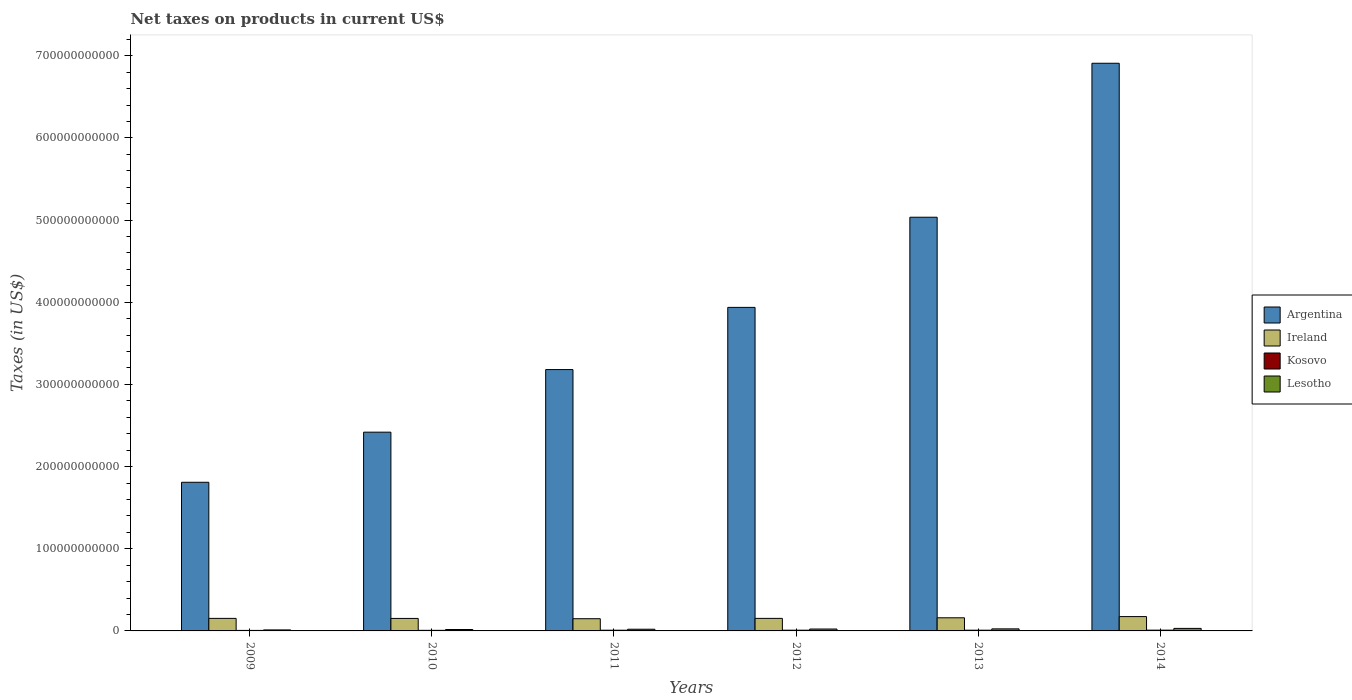How many groups of bars are there?
Keep it short and to the point. 6. Are the number of bars per tick equal to the number of legend labels?
Your response must be concise. Yes. How many bars are there on the 6th tick from the right?
Your answer should be compact. 4. What is the label of the 4th group of bars from the left?
Your answer should be compact. 2012. In how many cases, is the number of bars for a given year not equal to the number of legend labels?
Offer a very short reply. 0. What is the net taxes on products in Ireland in 2012?
Your answer should be compact. 1.53e+1. Across all years, what is the maximum net taxes on products in Ireland?
Your answer should be compact. 1.74e+1. Across all years, what is the minimum net taxes on products in Argentina?
Offer a terse response. 1.81e+11. In which year was the net taxes on products in Kosovo minimum?
Give a very brief answer. 2009. What is the total net taxes on products in Argentina in the graph?
Offer a terse response. 2.33e+12. What is the difference between the net taxes on products in Lesotho in 2010 and that in 2012?
Your answer should be compact. -5.82e+08. What is the difference between the net taxes on products in Ireland in 2011 and the net taxes on products in Kosovo in 2010?
Offer a terse response. 1.41e+1. What is the average net taxes on products in Ireland per year?
Offer a very short reply. 1.57e+1. In the year 2013, what is the difference between the net taxes on products in Lesotho and net taxes on products in Kosovo?
Give a very brief answer. 1.60e+09. What is the ratio of the net taxes on products in Argentina in 2010 to that in 2014?
Offer a very short reply. 0.35. What is the difference between the highest and the second highest net taxes on products in Argentina?
Provide a short and direct response. 1.87e+11. What is the difference between the highest and the lowest net taxes on products in Argentina?
Your answer should be compact. 5.10e+11. Is the sum of the net taxes on products in Argentina in 2011 and 2012 greater than the maximum net taxes on products in Ireland across all years?
Your answer should be compact. Yes. What does the 2nd bar from the left in 2009 represents?
Provide a succinct answer. Ireland. What does the 4th bar from the right in 2011 represents?
Ensure brevity in your answer.  Argentina. What is the difference between two consecutive major ticks on the Y-axis?
Your answer should be compact. 1.00e+11. Are the values on the major ticks of Y-axis written in scientific E-notation?
Offer a very short reply. No. Where does the legend appear in the graph?
Your answer should be compact. Center right. What is the title of the graph?
Your answer should be very brief. Net taxes on products in current US$. What is the label or title of the Y-axis?
Your answer should be very brief. Taxes (in US$). What is the Taxes (in US$) of Argentina in 2009?
Ensure brevity in your answer.  1.81e+11. What is the Taxes (in US$) of Ireland in 2009?
Provide a succinct answer. 1.53e+1. What is the Taxes (in US$) of Kosovo in 2009?
Your answer should be compact. 6.11e+08. What is the Taxes (in US$) in Lesotho in 2009?
Provide a succinct answer. 1.23e+09. What is the Taxes (in US$) of Argentina in 2010?
Your answer should be very brief. 2.42e+11. What is the Taxes (in US$) of Ireland in 2010?
Offer a very short reply. 1.52e+1. What is the Taxes (in US$) of Kosovo in 2010?
Give a very brief answer. 7.15e+08. What is the Taxes (in US$) in Lesotho in 2010?
Your answer should be very brief. 1.72e+09. What is the Taxes (in US$) of Argentina in 2011?
Give a very brief answer. 3.18e+11. What is the Taxes (in US$) of Ireland in 2011?
Ensure brevity in your answer.  1.49e+1. What is the Taxes (in US$) of Kosovo in 2011?
Provide a succinct answer. 8.70e+08. What is the Taxes (in US$) in Lesotho in 2011?
Your answer should be compact. 2.06e+09. What is the Taxes (in US$) of Argentina in 2012?
Offer a terse response. 3.94e+11. What is the Taxes (in US$) of Ireland in 2012?
Your answer should be very brief. 1.53e+1. What is the Taxes (in US$) of Kosovo in 2012?
Ensure brevity in your answer.  8.92e+08. What is the Taxes (in US$) in Lesotho in 2012?
Your answer should be very brief. 2.31e+09. What is the Taxes (in US$) in Argentina in 2013?
Provide a succinct answer. 5.03e+11. What is the Taxes (in US$) in Ireland in 2013?
Provide a short and direct response. 1.60e+1. What is the Taxes (in US$) of Kosovo in 2013?
Provide a short and direct response. 8.91e+08. What is the Taxes (in US$) in Lesotho in 2013?
Give a very brief answer. 2.49e+09. What is the Taxes (in US$) of Argentina in 2014?
Your answer should be very brief. 6.91e+11. What is the Taxes (in US$) in Ireland in 2014?
Your answer should be very brief. 1.74e+1. What is the Taxes (in US$) of Kosovo in 2014?
Keep it short and to the point. 9.50e+08. What is the Taxes (in US$) in Lesotho in 2014?
Ensure brevity in your answer.  3.06e+09. Across all years, what is the maximum Taxes (in US$) in Argentina?
Provide a short and direct response. 6.91e+11. Across all years, what is the maximum Taxes (in US$) of Ireland?
Provide a short and direct response. 1.74e+1. Across all years, what is the maximum Taxes (in US$) in Kosovo?
Make the answer very short. 9.50e+08. Across all years, what is the maximum Taxes (in US$) in Lesotho?
Offer a very short reply. 3.06e+09. Across all years, what is the minimum Taxes (in US$) in Argentina?
Offer a terse response. 1.81e+11. Across all years, what is the minimum Taxes (in US$) in Ireland?
Keep it short and to the point. 1.49e+1. Across all years, what is the minimum Taxes (in US$) of Kosovo?
Your response must be concise. 6.11e+08. Across all years, what is the minimum Taxes (in US$) of Lesotho?
Your answer should be very brief. 1.23e+09. What is the total Taxes (in US$) in Argentina in the graph?
Your answer should be compact. 2.33e+12. What is the total Taxes (in US$) of Ireland in the graph?
Your response must be concise. 9.40e+1. What is the total Taxes (in US$) of Kosovo in the graph?
Your answer should be compact. 4.93e+09. What is the total Taxes (in US$) in Lesotho in the graph?
Make the answer very short. 1.29e+1. What is the difference between the Taxes (in US$) of Argentina in 2009 and that in 2010?
Your answer should be compact. -6.10e+1. What is the difference between the Taxes (in US$) in Ireland in 2009 and that in 2010?
Give a very brief answer. 4.93e+07. What is the difference between the Taxes (in US$) in Kosovo in 2009 and that in 2010?
Make the answer very short. -1.04e+08. What is the difference between the Taxes (in US$) of Lesotho in 2009 and that in 2010?
Offer a very short reply. -4.92e+08. What is the difference between the Taxes (in US$) of Argentina in 2009 and that in 2011?
Ensure brevity in your answer.  -1.37e+11. What is the difference between the Taxes (in US$) of Ireland in 2009 and that in 2011?
Make the answer very short. 3.92e+08. What is the difference between the Taxes (in US$) in Kosovo in 2009 and that in 2011?
Ensure brevity in your answer.  -2.59e+08. What is the difference between the Taxes (in US$) in Lesotho in 2009 and that in 2011?
Provide a succinct answer. -8.29e+08. What is the difference between the Taxes (in US$) of Argentina in 2009 and that in 2012?
Your response must be concise. -2.13e+11. What is the difference between the Taxes (in US$) in Ireland in 2009 and that in 2012?
Your response must be concise. -3.98e+06. What is the difference between the Taxes (in US$) in Kosovo in 2009 and that in 2012?
Provide a succinct answer. -2.81e+08. What is the difference between the Taxes (in US$) of Lesotho in 2009 and that in 2012?
Your answer should be very brief. -1.07e+09. What is the difference between the Taxes (in US$) in Argentina in 2009 and that in 2013?
Your response must be concise. -3.23e+11. What is the difference between the Taxes (in US$) of Ireland in 2009 and that in 2013?
Offer a terse response. -7.23e+08. What is the difference between the Taxes (in US$) in Kosovo in 2009 and that in 2013?
Your answer should be compact. -2.80e+08. What is the difference between the Taxes (in US$) in Lesotho in 2009 and that in 2013?
Ensure brevity in your answer.  -1.26e+09. What is the difference between the Taxes (in US$) in Argentina in 2009 and that in 2014?
Your answer should be very brief. -5.10e+11. What is the difference between the Taxes (in US$) in Ireland in 2009 and that in 2014?
Offer a terse response. -2.19e+09. What is the difference between the Taxes (in US$) of Kosovo in 2009 and that in 2014?
Offer a terse response. -3.39e+08. What is the difference between the Taxes (in US$) of Lesotho in 2009 and that in 2014?
Give a very brief answer. -1.83e+09. What is the difference between the Taxes (in US$) in Argentina in 2010 and that in 2011?
Your answer should be very brief. -7.62e+1. What is the difference between the Taxes (in US$) in Ireland in 2010 and that in 2011?
Keep it short and to the point. 3.43e+08. What is the difference between the Taxes (in US$) of Kosovo in 2010 and that in 2011?
Provide a short and direct response. -1.55e+08. What is the difference between the Taxes (in US$) of Lesotho in 2010 and that in 2011?
Offer a terse response. -3.37e+08. What is the difference between the Taxes (in US$) of Argentina in 2010 and that in 2012?
Keep it short and to the point. -1.52e+11. What is the difference between the Taxes (in US$) in Ireland in 2010 and that in 2012?
Keep it short and to the point. -5.33e+07. What is the difference between the Taxes (in US$) in Kosovo in 2010 and that in 2012?
Provide a succinct answer. -1.77e+08. What is the difference between the Taxes (in US$) of Lesotho in 2010 and that in 2012?
Provide a succinct answer. -5.82e+08. What is the difference between the Taxes (in US$) in Argentina in 2010 and that in 2013?
Provide a succinct answer. -2.62e+11. What is the difference between the Taxes (in US$) in Ireland in 2010 and that in 2013?
Ensure brevity in your answer.  -7.73e+08. What is the difference between the Taxes (in US$) in Kosovo in 2010 and that in 2013?
Keep it short and to the point. -1.76e+08. What is the difference between the Taxes (in US$) of Lesotho in 2010 and that in 2013?
Provide a succinct answer. -7.69e+08. What is the difference between the Taxes (in US$) in Argentina in 2010 and that in 2014?
Provide a succinct answer. -4.49e+11. What is the difference between the Taxes (in US$) of Ireland in 2010 and that in 2014?
Give a very brief answer. -2.24e+09. What is the difference between the Taxes (in US$) of Kosovo in 2010 and that in 2014?
Keep it short and to the point. -2.35e+08. What is the difference between the Taxes (in US$) of Lesotho in 2010 and that in 2014?
Make the answer very short. -1.34e+09. What is the difference between the Taxes (in US$) in Argentina in 2011 and that in 2012?
Offer a very short reply. -7.57e+1. What is the difference between the Taxes (in US$) of Ireland in 2011 and that in 2012?
Give a very brief answer. -3.96e+08. What is the difference between the Taxes (in US$) of Kosovo in 2011 and that in 2012?
Provide a short and direct response. -2.21e+07. What is the difference between the Taxes (in US$) in Lesotho in 2011 and that in 2012?
Keep it short and to the point. -2.45e+08. What is the difference between the Taxes (in US$) of Argentina in 2011 and that in 2013?
Offer a terse response. -1.85e+11. What is the difference between the Taxes (in US$) in Ireland in 2011 and that in 2013?
Your answer should be very brief. -1.12e+09. What is the difference between the Taxes (in US$) in Kosovo in 2011 and that in 2013?
Offer a terse response. -2.14e+07. What is the difference between the Taxes (in US$) of Lesotho in 2011 and that in 2013?
Provide a short and direct response. -4.32e+08. What is the difference between the Taxes (in US$) of Argentina in 2011 and that in 2014?
Offer a very short reply. -3.73e+11. What is the difference between the Taxes (in US$) of Ireland in 2011 and that in 2014?
Your answer should be very brief. -2.58e+09. What is the difference between the Taxes (in US$) in Kosovo in 2011 and that in 2014?
Provide a succinct answer. -8.03e+07. What is the difference between the Taxes (in US$) of Lesotho in 2011 and that in 2014?
Provide a succinct answer. -1.00e+09. What is the difference between the Taxes (in US$) in Argentina in 2012 and that in 2013?
Provide a short and direct response. -1.10e+11. What is the difference between the Taxes (in US$) in Ireland in 2012 and that in 2013?
Provide a short and direct response. -7.19e+08. What is the difference between the Taxes (in US$) of Lesotho in 2012 and that in 2013?
Provide a short and direct response. -1.87e+08. What is the difference between the Taxes (in US$) in Argentina in 2012 and that in 2014?
Ensure brevity in your answer.  -2.97e+11. What is the difference between the Taxes (in US$) of Ireland in 2012 and that in 2014?
Offer a terse response. -2.18e+09. What is the difference between the Taxes (in US$) of Kosovo in 2012 and that in 2014?
Your answer should be very brief. -5.82e+07. What is the difference between the Taxes (in US$) in Lesotho in 2012 and that in 2014?
Make the answer very short. -7.56e+08. What is the difference between the Taxes (in US$) of Argentina in 2013 and that in 2014?
Ensure brevity in your answer.  -1.87e+11. What is the difference between the Taxes (in US$) of Ireland in 2013 and that in 2014?
Make the answer very short. -1.47e+09. What is the difference between the Taxes (in US$) of Kosovo in 2013 and that in 2014?
Give a very brief answer. -5.89e+07. What is the difference between the Taxes (in US$) in Lesotho in 2013 and that in 2014?
Keep it short and to the point. -5.69e+08. What is the difference between the Taxes (in US$) in Argentina in 2009 and the Taxes (in US$) in Ireland in 2010?
Offer a very short reply. 1.66e+11. What is the difference between the Taxes (in US$) of Argentina in 2009 and the Taxes (in US$) of Kosovo in 2010?
Your answer should be very brief. 1.80e+11. What is the difference between the Taxes (in US$) of Argentina in 2009 and the Taxes (in US$) of Lesotho in 2010?
Your response must be concise. 1.79e+11. What is the difference between the Taxes (in US$) in Ireland in 2009 and the Taxes (in US$) in Kosovo in 2010?
Provide a short and direct response. 1.45e+1. What is the difference between the Taxes (in US$) of Ireland in 2009 and the Taxes (in US$) of Lesotho in 2010?
Offer a terse response. 1.35e+1. What is the difference between the Taxes (in US$) of Kosovo in 2009 and the Taxes (in US$) of Lesotho in 2010?
Your answer should be very brief. -1.11e+09. What is the difference between the Taxes (in US$) of Argentina in 2009 and the Taxes (in US$) of Ireland in 2011?
Offer a very short reply. 1.66e+11. What is the difference between the Taxes (in US$) of Argentina in 2009 and the Taxes (in US$) of Kosovo in 2011?
Your response must be concise. 1.80e+11. What is the difference between the Taxes (in US$) of Argentina in 2009 and the Taxes (in US$) of Lesotho in 2011?
Provide a succinct answer. 1.79e+11. What is the difference between the Taxes (in US$) of Ireland in 2009 and the Taxes (in US$) of Kosovo in 2011?
Ensure brevity in your answer.  1.44e+1. What is the difference between the Taxes (in US$) in Ireland in 2009 and the Taxes (in US$) in Lesotho in 2011?
Make the answer very short. 1.32e+1. What is the difference between the Taxes (in US$) in Kosovo in 2009 and the Taxes (in US$) in Lesotho in 2011?
Provide a succinct answer. -1.45e+09. What is the difference between the Taxes (in US$) in Argentina in 2009 and the Taxes (in US$) in Ireland in 2012?
Provide a succinct answer. 1.66e+11. What is the difference between the Taxes (in US$) of Argentina in 2009 and the Taxes (in US$) of Kosovo in 2012?
Provide a short and direct response. 1.80e+11. What is the difference between the Taxes (in US$) of Argentina in 2009 and the Taxes (in US$) of Lesotho in 2012?
Your response must be concise. 1.79e+11. What is the difference between the Taxes (in US$) of Ireland in 2009 and the Taxes (in US$) of Kosovo in 2012?
Your answer should be compact. 1.44e+1. What is the difference between the Taxes (in US$) in Ireland in 2009 and the Taxes (in US$) in Lesotho in 2012?
Provide a succinct answer. 1.29e+1. What is the difference between the Taxes (in US$) of Kosovo in 2009 and the Taxes (in US$) of Lesotho in 2012?
Ensure brevity in your answer.  -1.70e+09. What is the difference between the Taxes (in US$) in Argentina in 2009 and the Taxes (in US$) in Ireland in 2013?
Your answer should be very brief. 1.65e+11. What is the difference between the Taxes (in US$) in Argentina in 2009 and the Taxes (in US$) in Kosovo in 2013?
Your response must be concise. 1.80e+11. What is the difference between the Taxes (in US$) in Argentina in 2009 and the Taxes (in US$) in Lesotho in 2013?
Provide a succinct answer. 1.78e+11. What is the difference between the Taxes (in US$) of Ireland in 2009 and the Taxes (in US$) of Kosovo in 2013?
Your answer should be very brief. 1.44e+1. What is the difference between the Taxes (in US$) of Ireland in 2009 and the Taxes (in US$) of Lesotho in 2013?
Your response must be concise. 1.28e+1. What is the difference between the Taxes (in US$) in Kosovo in 2009 and the Taxes (in US$) in Lesotho in 2013?
Offer a very short reply. -1.88e+09. What is the difference between the Taxes (in US$) in Argentina in 2009 and the Taxes (in US$) in Ireland in 2014?
Make the answer very short. 1.63e+11. What is the difference between the Taxes (in US$) in Argentina in 2009 and the Taxes (in US$) in Kosovo in 2014?
Ensure brevity in your answer.  1.80e+11. What is the difference between the Taxes (in US$) in Argentina in 2009 and the Taxes (in US$) in Lesotho in 2014?
Ensure brevity in your answer.  1.78e+11. What is the difference between the Taxes (in US$) in Ireland in 2009 and the Taxes (in US$) in Kosovo in 2014?
Keep it short and to the point. 1.43e+1. What is the difference between the Taxes (in US$) in Ireland in 2009 and the Taxes (in US$) in Lesotho in 2014?
Offer a very short reply. 1.22e+1. What is the difference between the Taxes (in US$) in Kosovo in 2009 and the Taxes (in US$) in Lesotho in 2014?
Your answer should be compact. -2.45e+09. What is the difference between the Taxes (in US$) in Argentina in 2010 and the Taxes (in US$) in Ireland in 2011?
Your answer should be compact. 2.27e+11. What is the difference between the Taxes (in US$) in Argentina in 2010 and the Taxes (in US$) in Kosovo in 2011?
Offer a terse response. 2.41e+11. What is the difference between the Taxes (in US$) in Argentina in 2010 and the Taxes (in US$) in Lesotho in 2011?
Provide a succinct answer. 2.40e+11. What is the difference between the Taxes (in US$) of Ireland in 2010 and the Taxes (in US$) of Kosovo in 2011?
Your answer should be compact. 1.43e+1. What is the difference between the Taxes (in US$) of Ireland in 2010 and the Taxes (in US$) of Lesotho in 2011?
Your answer should be very brief. 1.31e+1. What is the difference between the Taxes (in US$) in Kosovo in 2010 and the Taxes (in US$) in Lesotho in 2011?
Offer a very short reply. -1.35e+09. What is the difference between the Taxes (in US$) of Argentina in 2010 and the Taxes (in US$) of Ireland in 2012?
Offer a terse response. 2.27e+11. What is the difference between the Taxes (in US$) in Argentina in 2010 and the Taxes (in US$) in Kosovo in 2012?
Give a very brief answer. 2.41e+11. What is the difference between the Taxes (in US$) of Argentina in 2010 and the Taxes (in US$) of Lesotho in 2012?
Give a very brief answer. 2.40e+11. What is the difference between the Taxes (in US$) of Ireland in 2010 and the Taxes (in US$) of Kosovo in 2012?
Your answer should be compact. 1.43e+1. What is the difference between the Taxes (in US$) in Ireland in 2010 and the Taxes (in US$) in Lesotho in 2012?
Ensure brevity in your answer.  1.29e+1. What is the difference between the Taxes (in US$) in Kosovo in 2010 and the Taxes (in US$) in Lesotho in 2012?
Your answer should be compact. -1.59e+09. What is the difference between the Taxes (in US$) in Argentina in 2010 and the Taxes (in US$) in Ireland in 2013?
Provide a succinct answer. 2.26e+11. What is the difference between the Taxes (in US$) of Argentina in 2010 and the Taxes (in US$) of Kosovo in 2013?
Your response must be concise. 2.41e+11. What is the difference between the Taxes (in US$) in Argentina in 2010 and the Taxes (in US$) in Lesotho in 2013?
Offer a very short reply. 2.39e+11. What is the difference between the Taxes (in US$) of Ireland in 2010 and the Taxes (in US$) of Kosovo in 2013?
Provide a short and direct response. 1.43e+1. What is the difference between the Taxes (in US$) of Ireland in 2010 and the Taxes (in US$) of Lesotho in 2013?
Ensure brevity in your answer.  1.27e+1. What is the difference between the Taxes (in US$) of Kosovo in 2010 and the Taxes (in US$) of Lesotho in 2013?
Offer a very short reply. -1.78e+09. What is the difference between the Taxes (in US$) of Argentina in 2010 and the Taxes (in US$) of Ireland in 2014?
Your response must be concise. 2.24e+11. What is the difference between the Taxes (in US$) in Argentina in 2010 and the Taxes (in US$) in Kosovo in 2014?
Offer a terse response. 2.41e+11. What is the difference between the Taxes (in US$) in Argentina in 2010 and the Taxes (in US$) in Lesotho in 2014?
Offer a very short reply. 2.39e+11. What is the difference between the Taxes (in US$) in Ireland in 2010 and the Taxes (in US$) in Kosovo in 2014?
Make the answer very short. 1.43e+1. What is the difference between the Taxes (in US$) in Ireland in 2010 and the Taxes (in US$) in Lesotho in 2014?
Keep it short and to the point. 1.21e+1. What is the difference between the Taxes (in US$) in Kosovo in 2010 and the Taxes (in US$) in Lesotho in 2014?
Provide a succinct answer. -2.35e+09. What is the difference between the Taxes (in US$) of Argentina in 2011 and the Taxes (in US$) of Ireland in 2012?
Give a very brief answer. 3.03e+11. What is the difference between the Taxes (in US$) in Argentina in 2011 and the Taxes (in US$) in Kosovo in 2012?
Give a very brief answer. 3.17e+11. What is the difference between the Taxes (in US$) in Argentina in 2011 and the Taxes (in US$) in Lesotho in 2012?
Provide a succinct answer. 3.16e+11. What is the difference between the Taxes (in US$) in Ireland in 2011 and the Taxes (in US$) in Kosovo in 2012?
Ensure brevity in your answer.  1.40e+1. What is the difference between the Taxes (in US$) of Ireland in 2011 and the Taxes (in US$) of Lesotho in 2012?
Keep it short and to the point. 1.26e+1. What is the difference between the Taxes (in US$) in Kosovo in 2011 and the Taxes (in US$) in Lesotho in 2012?
Ensure brevity in your answer.  -1.44e+09. What is the difference between the Taxes (in US$) of Argentina in 2011 and the Taxes (in US$) of Ireland in 2013?
Give a very brief answer. 3.02e+11. What is the difference between the Taxes (in US$) in Argentina in 2011 and the Taxes (in US$) in Kosovo in 2013?
Your answer should be very brief. 3.17e+11. What is the difference between the Taxes (in US$) of Argentina in 2011 and the Taxes (in US$) of Lesotho in 2013?
Offer a terse response. 3.16e+11. What is the difference between the Taxes (in US$) in Ireland in 2011 and the Taxes (in US$) in Kosovo in 2013?
Make the answer very short. 1.40e+1. What is the difference between the Taxes (in US$) in Ireland in 2011 and the Taxes (in US$) in Lesotho in 2013?
Keep it short and to the point. 1.24e+1. What is the difference between the Taxes (in US$) of Kosovo in 2011 and the Taxes (in US$) of Lesotho in 2013?
Your answer should be compact. -1.62e+09. What is the difference between the Taxes (in US$) in Argentina in 2011 and the Taxes (in US$) in Ireland in 2014?
Provide a succinct answer. 3.01e+11. What is the difference between the Taxes (in US$) in Argentina in 2011 and the Taxes (in US$) in Kosovo in 2014?
Ensure brevity in your answer.  3.17e+11. What is the difference between the Taxes (in US$) in Argentina in 2011 and the Taxes (in US$) in Lesotho in 2014?
Your answer should be compact. 3.15e+11. What is the difference between the Taxes (in US$) in Ireland in 2011 and the Taxes (in US$) in Kosovo in 2014?
Your answer should be very brief. 1.39e+1. What is the difference between the Taxes (in US$) in Ireland in 2011 and the Taxes (in US$) in Lesotho in 2014?
Give a very brief answer. 1.18e+1. What is the difference between the Taxes (in US$) in Kosovo in 2011 and the Taxes (in US$) in Lesotho in 2014?
Make the answer very short. -2.19e+09. What is the difference between the Taxes (in US$) in Argentina in 2012 and the Taxes (in US$) in Ireland in 2013?
Give a very brief answer. 3.78e+11. What is the difference between the Taxes (in US$) in Argentina in 2012 and the Taxes (in US$) in Kosovo in 2013?
Offer a very short reply. 3.93e+11. What is the difference between the Taxes (in US$) of Argentina in 2012 and the Taxes (in US$) of Lesotho in 2013?
Provide a short and direct response. 3.91e+11. What is the difference between the Taxes (in US$) of Ireland in 2012 and the Taxes (in US$) of Kosovo in 2013?
Make the answer very short. 1.44e+1. What is the difference between the Taxes (in US$) of Ireland in 2012 and the Taxes (in US$) of Lesotho in 2013?
Make the answer very short. 1.28e+1. What is the difference between the Taxes (in US$) of Kosovo in 2012 and the Taxes (in US$) of Lesotho in 2013?
Provide a succinct answer. -1.60e+09. What is the difference between the Taxes (in US$) in Argentina in 2012 and the Taxes (in US$) in Ireland in 2014?
Make the answer very short. 3.76e+11. What is the difference between the Taxes (in US$) in Argentina in 2012 and the Taxes (in US$) in Kosovo in 2014?
Offer a terse response. 3.93e+11. What is the difference between the Taxes (in US$) in Argentina in 2012 and the Taxes (in US$) in Lesotho in 2014?
Keep it short and to the point. 3.91e+11. What is the difference between the Taxes (in US$) of Ireland in 2012 and the Taxes (in US$) of Kosovo in 2014?
Provide a succinct answer. 1.43e+1. What is the difference between the Taxes (in US$) of Ireland in 2012 and the Taxes (in US$) of Lesotho in 2014?
Your answer should be very brief. 1.22e+1. What is the difference between the Taxes (in US$) in Kosovo in 2012 and the Taxes (in US$) in Lesotho in 2014?
Your answer should be compact. -2.17e+09. What is the difference between the Taxes (in US$) of Argentina in 2013 and the Taxes (in US$) of Ireland in 2014?
Make the answer very short. 4.86e+11. What is the difference between the Taxes (in US$) in Argentina in 2013 and the Taxes (in US$) in Kosovo in 2014?
Keep it short and to the point. 5.03e+11. What is the difference between the Taxes (in US$) in Argentina in 2013 and the Taxes (in US$) in Lesotho in 2014?
Offer a terse response. 5.00e+11. What is the difference between the Taxes (in US$) in Ireland in 2013 and the Taxes (in US$) in Kosovo in 2014?
Your answer should be compact. 1.50e+1. What is the difference between the Taxes (in US$) of Ireland in 2013 and the Taxes (in US$) of Lesotho in 2014?
Offer a terse response. 1.29e+1. What is the difference between the Taxes (in US$) of Kosovo in 2013 and the Taxes (in US$) of Lesotho in 2014?
Your answer should be compact. -2.17e+09. What is the average Taxes (in US$) in Argentina per year?
Provide a succinct answer. 3.88e+11. What is the average Taxes (in US$) of Ireland per year?
Provide a short and direct response. 1.57e+1. What is the average Taxes (in US$) in Kosovo per year?
Your response must be concise. 8.21e+08. What is the average Taxes (in US$) of Lesotho per year?
Your answer should be very brief. 2.15e+09. In the year 2009, what is the difference between the Taxes (in US$) of Argentina and Taxes (in US$) of Ireland?
Ensure brevity in your answer.  1.66e+11. In the year 2009, what is the difference between the Taxes (in US$) of Argentina and Taxes (in US$) of Kosovo?
Ensure brevity in your answer.  1.80e+11. In the year 2009, what is the difference between the Taxes (in US$) in Argentina and Taxes (in US$) in Lesotho?
Make the answer very short. 1.80e+11. In the year 2009, what is the difference between the Taxes (in US$) in Ireland and Taxes (in US$) in Kosovo?
Your response must be concise. 1.46e+1. In the year 2009, what is the difference between the Taxes (in US$) in Ireland and Taxes (in US$) in Lesotho?
Provide a short and direct response. 1.40e+1. In the year 2009, what is the difference between the Taxes (in US$) of Kosovo and Taxes (in US$) of Lesotho?
Your answer should be compact. -6.21e+08. In the year 2010, what is the difference between the Taxes (in US$) of Argentina and Taxes (in US$) of Ireland?
Offer a terse response. 2.27e+11. In the year 2010, what is the difference between the Taxes (in US$) of Argentina and Taxes (in US$) of Kosovo?
Your answer should be compact. 2.41e+11. In the year 2010, what is the difference between the Taxes (in US$) in Argentina and Taxes (in US$) in Lesotho?
Keep it short and to the point. 2.40e+11. In the year 2010, what is the difference between the Taxes (in US$) in Ireland and Taxes (in US$) in Kosovo?
Your answer should be compact. 1.45e+1. In the year 2010, what is the difference between the Taxes (in US$) of Ireland and Taxes (in US$) of Lesotho?
Offer a terse response. 1.35e+1. In the year 2010, what is the difference between the Taxes (in US$) in Kosovo and Taxes (in US$) in Lesotho?
Make the answer very short. -1.01e+09. In the year 2011, what is the difference between the Taxes (in US$) in Argentina and Taxes (in US$) in Ireland?
Your answer should be compact. 3.03e+11. In the year 2011, what is the difference between the Taxes (in US$) in Argentina and Taxes (in US$) in Kosovo?
Ensure brevity in your answer.  3.17e+11. In the year 2011, what is the difference between the Taxes (in US$) of Argentina and Taxes (in US$) of Lesotho?
Ensure brevity in your answer.  3.16e+11. In the year 2011, what is the difference between the Taxes (in US$) in Ireland and Taxes (in US$) in Kosovo?
Give a very brief answer. 1.40e+1. In the year 2011, what is the difference between the Taxes (in US$) of Ireland and Taxes (in US$) of Lesotho?
Make the answer very short. 1.28e+1. In the year 2011, what is the difference between the Taxes (in US$) of Kosovo and Taxes (in US$) of Lesotho?
Make the answer very short. -1.19e+09. In the year 2012, what is the difference between the Taxes (in US$) in Argentina and Taxes (in US$) in Ireland?
Your response must be concise. 3.78e+11. In the year 2012, what is the difference between the Taxes (in US$) in Argentina and Taxes (in US$) in Kosovo?
Provide a short and direct response. 3.93e+11. In the year 2012, what is the difference between the Taxes (in US$) in Argentina and Taxes (in US$) in Lesotho?
Offer a very short reply. 3.91e+11. In the year 2012, what is the difference between the Taxes (in US$) in Ireland and Taxes (in US$) in Kosovo?
Provide a succinct answer. 1.44e+1. In the year 2012, what is the difference between the Taxes (in US$) in Ireland and Taxes (in US$) in Lesotho?
Give a very brief answer. 1.29e+1. In the year 2012, what is the difference between the Taxes (in US$) in Kosovo and Taxes (in US$) in Lesotho?
Provide a short and direct response. -1.41e+09. In the year 2013, what is the difference between the Taxes (in US$) in Argentina and Taxes (in US$) in Ireland?
Ensure brevity in your answer.  4.87e+11. In the year 2013, what is the difference between the Taxes (in US$) in Argentina and Taxes (in US$) in Kosovo?
Your answer should be compact. 5.03e+11. In the year 2013, what is the difference between the Taxes (in US$) in Argentina and Taxes (in US$) in Lesotho?
Your response must be concise. 5.01e+11. In the year 2013, what is the difference between the Taxes (in US$) in Ireland and Taxes (in US$) in Kosovo?
Offer a very short reply. 1.51e+1. In the year 2013, what is the difference between the Taxes (in US$) in Ireland and Taxes (in US$) in Lesotho?
Offer a very short reply. 1.35e+1. In the year 2013, what is the difference between the Taxes (in US$) of Kosovo and Taxes (in US$) of Lesotho?
Keep it short and to the point. -1.60e+09. In the year 2014, what is the difference between the Taxes (in US$) of Argentina and Taxes (in US$) of Ireland?
Make the answer very short. 6.73e+11. In the year 2014, what is the difference between the Taxes (in US$) of Argentina and Taxes (in US$) of Kosovo?
Your response must be concise. 6.90e+11. In the year 2014, what is the difference between the Taxes (in US$) of Argentina and Taxes (in US$) of Lesotho?
Offer a very short reply. 6.88e+11. In the year 2014, what is the difference between the Taxes (in US$) of Ireland and Taxes (in US$) of Kosovo?
Offer a terse response. 1.65e+1. In the year 2014, what is the difference between the Taxes (in US$) of Ireland and Taxes (in US$) of Lesotho?
Give a very brief answer. 1.44e+1. In the year 2014, what is the difference between the Taxes (in US$) in Kosovo and Taxes (in US$) in Lesotho?
Offer a terse response. -2.11e+09. What is the ratio of the Taxes (in US$) of Argentina in 2009 to that in 2010?
Your answer should be compact. 0.75. What is the ratio of the Taxes (in US$) in Ireland in 2009 to that in 2010?
Keep it short and to the point. 1. What is the ratio of the Taxes (in US$) in Kosovo in 2009 to that in 2010?
Keep it short and to the point. 0.85. What is the ratio of the Taxes (in US$) of Lesotho in 2009 to that in 2010?
Give a very brief answer. 0.71. What is the ratio of the Taxes (in US$) of Argentina in 2009 to that in 2011?
Your response must be concise. 0.57. What is the ratio of the Taxes (in US$) in Ireland in 2009 to that in 2011?
Offer a very short reply. 1.03. What is the ratio of the Taxes (in US$) in Kosovo in 2009 to that in 2011?
Offer a very short reply. 0.7. What is the ratio of the Taxes (in US$) in Lesotho in 2009 to that in 2011?
Your answer should be compact. 0.6. What is the ratio of the Taxes (in US$) in Argentina in 2009 to that in 2012?
Your response must be concise. 0.46. What is the ratio of the Taxes (in US$) of Kosovo in 2009 to that in 2012?
Give a very brief answer. 0.68. What is the ratio of the Taxes (in US$) in Lesotho in 2009 to that in 2012?
Provide a succinct answer. 0.53. What is the ratio of the Taxes (in US$) in Argentina in 2009 to that in 2013?
Your answer should be compact. 0.36. What is the ratio of the Taxes (in US$) of Ireland in 2009 to that in 2013?
Provide a succinct answer. 0.95. What is the ratio of the Taxes (in US$) in Kosovo in 2009 to that in 2013?
Your answer should be very brief. 0.69. What is the ratio of the Taxes (in US$) in Lesotho in 2009 to that in 2013?
Your response must be concise. 0.49. What is the ratio of the Taxes (in US$) in Argentina in 2009 to that in 2014?
Ensure brevity in your answer.  0.26. What is the ratio of the Taxes (in US$) of Ireland in 2009 to that in 2014?
Your response must be concise. 0.87. What is the ratio of the Taxes (in US$) of Kosovo in 2009 to that in 2014?
Offer a very short reply. 0.64. What is the ratio of the Taxes (in US$) of Lesotho in 2009 to that in 2014?
Keep it short and to the point. 0.4. What is the ratio of the Taxes (in US$) in Argentina in 2010 to that in 2011?
Give a very brief answer. 0.76. What is the ratio of the Taxes (in US$) in Ireland in 2010 to that in 2011?
Ensure brevity in your answer.  1.02. What is the ratio of the Taxes (in US$) of Kosovo in 2010 to that in 2011?
Make the answer very short. 0.82. What is the ratio of the Taxes (in US$) of Lesotho in 2010 to that in 2011?
Give a very brief answer. 0.84. What is the ratio of the Taxes (in US$) in Argentina in 2010 to that in 2012?
Give a very brief answer. 0.61. What is the ratio of the Taxes (in US$) in Kosovo in 2010 to that in 2012?
Your answer should be very brief. 0.8. What is the ratio of the Taxes (in US$) of Lesotho in 2010 to that in 2012?
Offer a very short reply. 0.75. What is the ratio of the Taxes (in US$) of Argentina in 2010 to that in 2013?
Give a very brief answer. 0.48. What is the ratio of the Taxes (in US$) in Ireland in 2010 to that in 2013?
Ensure brevity in your answer.  0.95. What is the ratio of the Taxes (in US$) of Kosovo in 2010 to that in 2013?
Offer a terse response. 0.8. What is the ratio of the Taxes (in US$) in Lesotho in 2010 to that in 2013?
Provide a succinct answer. 0.69. What is the ratio of the Taxes (in US$) in Argentina in 2010 to that in 2014?
Keep it short and to the point. 0.35. What is the ratio of the Taxes (in US$) of Ireland in 2010 to that in 2014?
Keep it short and to the point. 0.87. What is the ratio of the Taxes (in US$) in Kosovo in 2010 to that in 2014?
Provide a succinct answer. 0.75. What is the ratio of the Taxes (in US$) of Lesotho in 2010 to that in 2014?
Your response must be concise. 0.56. What is the ratio of the Taxes (in US$) of Argentina in 2011 to that in 2012?
Your answer should be very brief. 0.81. What is the ratio of the Taxes (in US$) in Kosovo in 2011 to that in 2012?
Keep it short and to the point. 0.98. What is the ratio of the Taxes (in US$) of Lesotho in 2011 to that in 2012?
Ensure brevity in your answer.  0.89. What is the ratio of the Taxes (in US$) of Argentina in 2011 to that in 2013?
Your response must be concise. 0.63. What is the ratio of the Taxes (in US$) in Ireland in 2011 to that in 2013?
Offer a very short reply. 0.93. What is the ratio of the Taxes (in US$) in Kosovo in 2011 to that in 2013?
Make the answer very short. 0.98. What is the ratio of the Taxes (in US$) in Lesotho in 2011 to that in 2013?
Give a very brief answer. 0.83. What is the ratio of the Taxes (in US$) of Argentina in 2011 to that in 2014?
Keep it short and to the point. 0.46. What is the ratio of the Taxes (in US$) in Ireland in 2011 to that in 2014?
Your answer should be very brief. 0.85. What is the ratio of the Taxes (in US$) in Kosovo in 2011 to that in 2014?
Provide a short and direct response. 0.92. What is the ratio of the Taxes (in US$) of Lesotho in 2011 to that in 2014?
Give a very brief answer. 0.67. What is the ratio of the Taxes (in US$) in Argentina in 2012 to that in 2013?
Give a very brief answer. 0.78. What is the ratio of the Taxes (in US$) of Ireland in 2012 to that in 2013?
Give a very brief answer. 0.95. What is the ratio of the Taxes (in US$) in Lesotho in 2012 to that in 2013?
Provide a succinct answer. 0.93. What is the ratio of the Taxes (in US$) in Argentina in 2012 to that in 2014?
Give a very brief answer. 0.57. What is the ratio of the Taxes (in US$) of Ireland in 2012 to that in 2014?
Ensure brevity in your answer.  0.87. What is the ratio of the Taxes (in US$) in Kosovo in 2012 to that in 2014?
Provide a short and direct response. 0.94. What is the ratio of the Taxes (in US$) in Lesotho in 2012 to that in 2014?
Offer a terse response. 0.75. What is the ratio of the Taxes (in US$) of Argentina in 2013 to that in 2014?
Provide a succinct answer. 0.73. What is the ratio of the Taxes (in US$) in Ireland in 2013 to that in 2014?
Keep it short and to the point. 0.92. What is the ratio of the Taxes (in US$) of Kosovo in 2013 to that in 2014?
Keep it short and to the point. 0.94. What is the ratio of the Taxes (in US$) of Lesotho in 2013 to that in 2014?
Provide a short and direct response. 0.81. What is the difference between the highest and the second highest Taxes (in US$) in Argentina?
Provide a succinct answer. 1.87e+11. What is the difference between the highest and the second highest Taxes (in US$) of Ireland?
Offer a terse response. 1.47e+09. What is the difference between the highest and the second highest Taxes (in US$) in Kosovo?
Provide a short and direct response. 5.82e+07. What is the difference between the highest and the second highest Taxes (in US$) of Lesotho?
Your response must be concise. 5.69e+08. What is the difference between the highest and the lowest Taxes (in US$) of Argentina?
Your answer should be very brief. 5.10e+11. What is the difference between the highest and the lowest Taxes (in US$) of Ireland?
Your response must be concise. 2.58e+09. What is the difference between the highest and the lowest Taxes (in US$) in Kosovo?
Your answer should be compact. 3.39e+08. What is the difference between the highest and the lowest Taxes (in US$) of Lesotho?
Provide a short and direct response. 1.83e+09. 